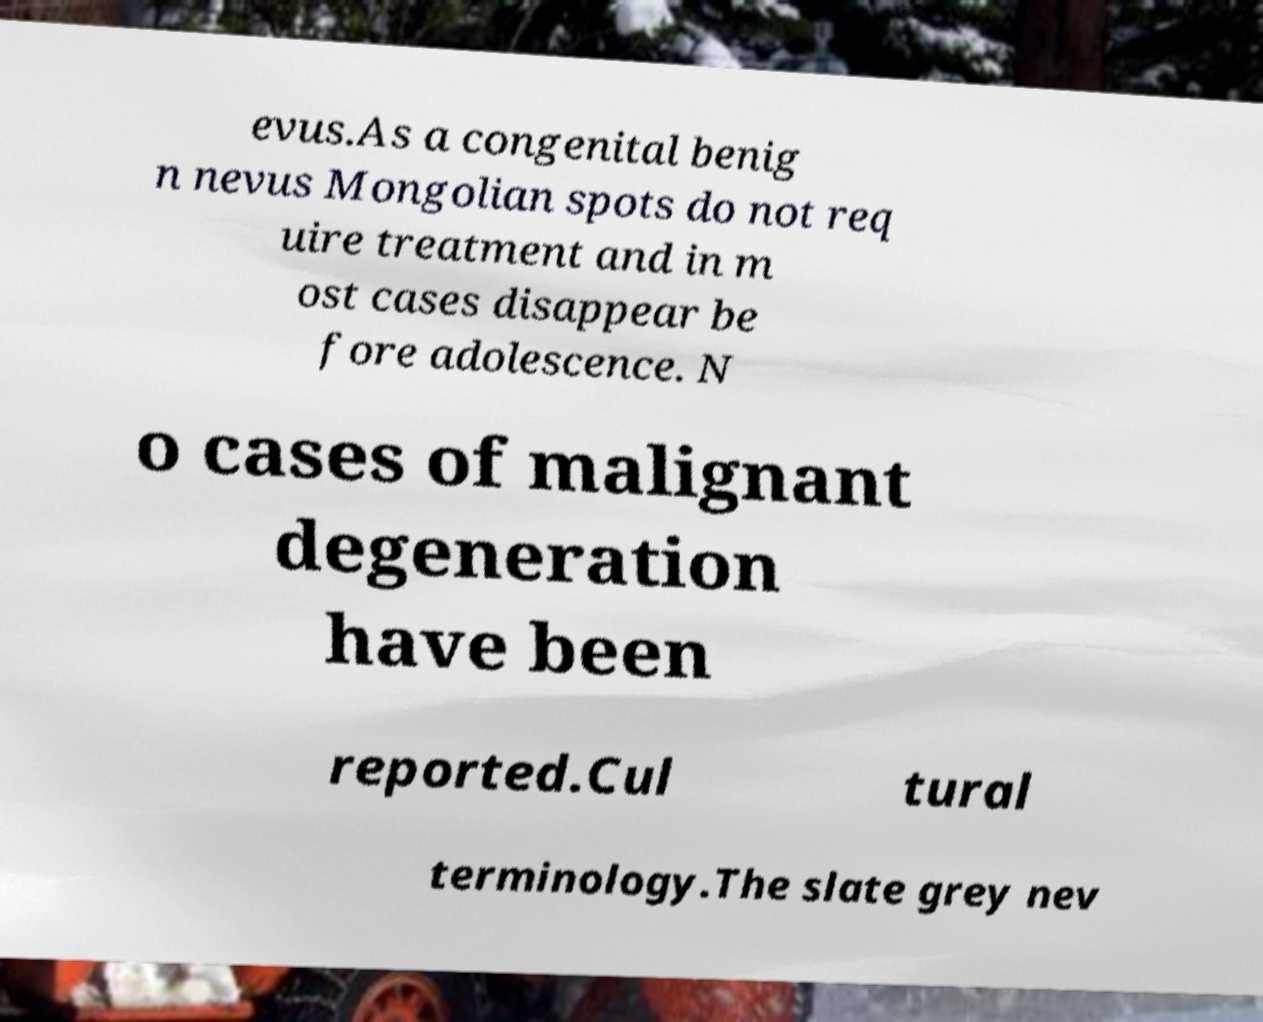Can you accurately transcribe the text from the provided image for me? evus.As a congenital benig n nevus Mongolian spots do not req uire treatment and in m ost cases disappear be fore adolescence. N o cases of malignant degeneration have been reported.Cul tural terminology.The slate grey nev 